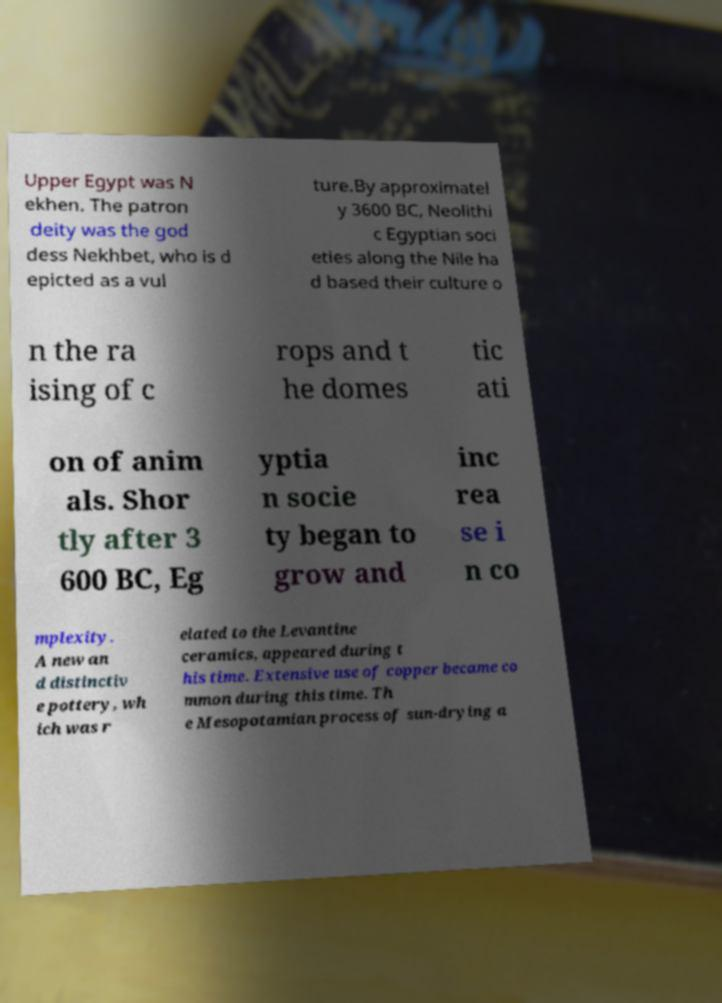There's text embedded in this image that I need extracted. Can you transcribe it verbatim? Upper Egypt was N ekhen. The patron deity was the god dess Nekhbet, who is d epicted as a vul ture.By approximatel y 3600 BC, Neolithi c Egyptian soci eties along the Nile ha d based their culture o n the ra ising of c rops and t he domes tic ati on of anim als. Shor tly after 3 600 BC, Eg yptia n socie ty began to grow and inc rea se i n co mplexity. A new an d distinctiv e pottery, wh ich was r elated to the Levantine ceramics, appeared during t his time. Extensive use of copper became co mmon during this time. Th e Mesopotamian process of sun-drying a 